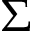<formula> <loc_0><loc_0><loc_500><loc_500>\Sigma</formula> 